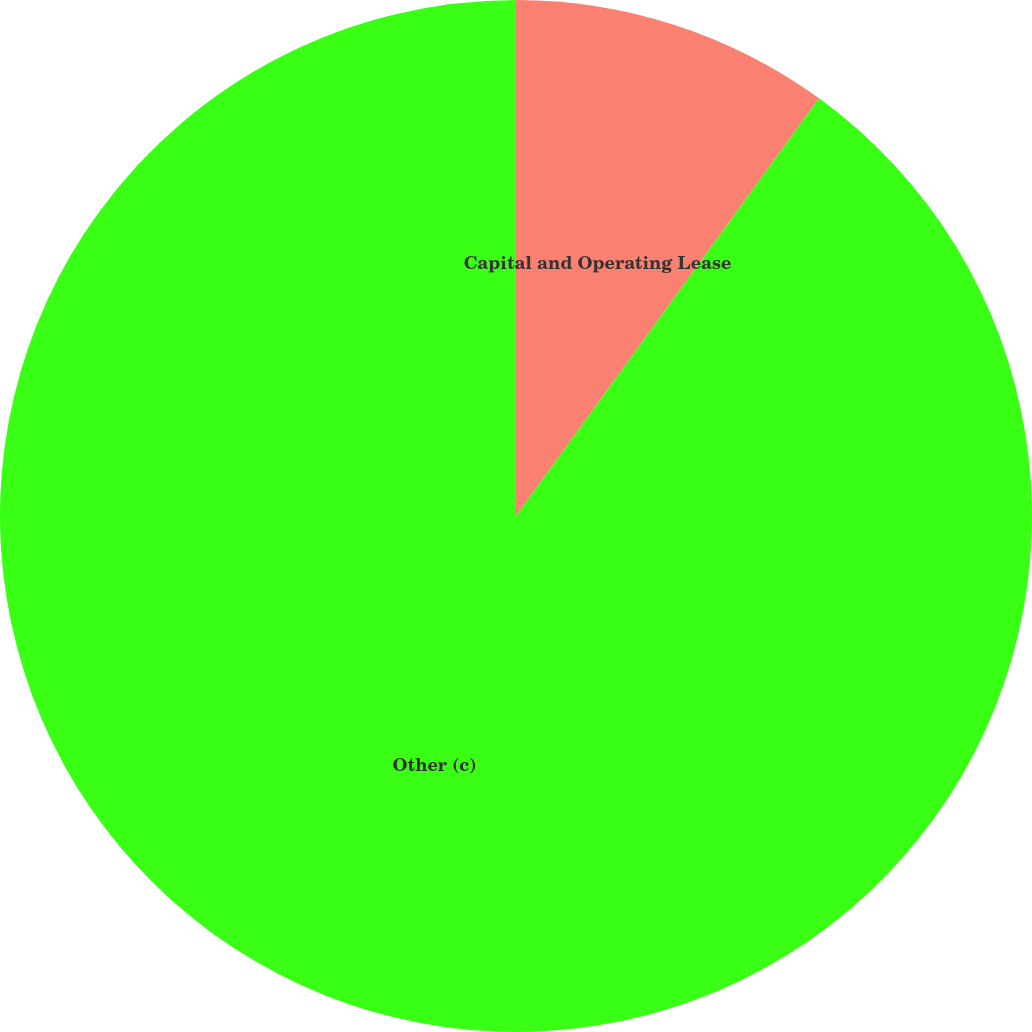<chart> <loc_0><loc_0><loc_500><loc_500><pie_chart><fcel>Capital and Operating Lease<fcel>Other (c)<nl><fcel>9.99%<fcel>90.01%<nl></chart> 